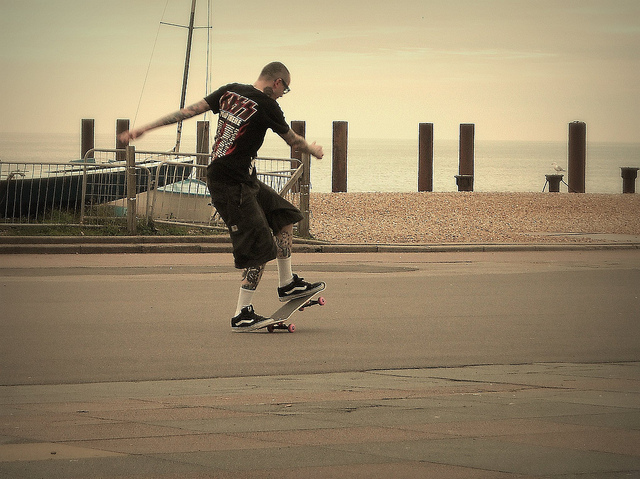<image>Where is a bus stop? It is unknown where the bus stop is. It's not clearly seen in the image. Where is a bus stop? It is unclear where the bus stop is located. It may be somewhere nearby or on the right side, but it cannot be determined from the given information. 